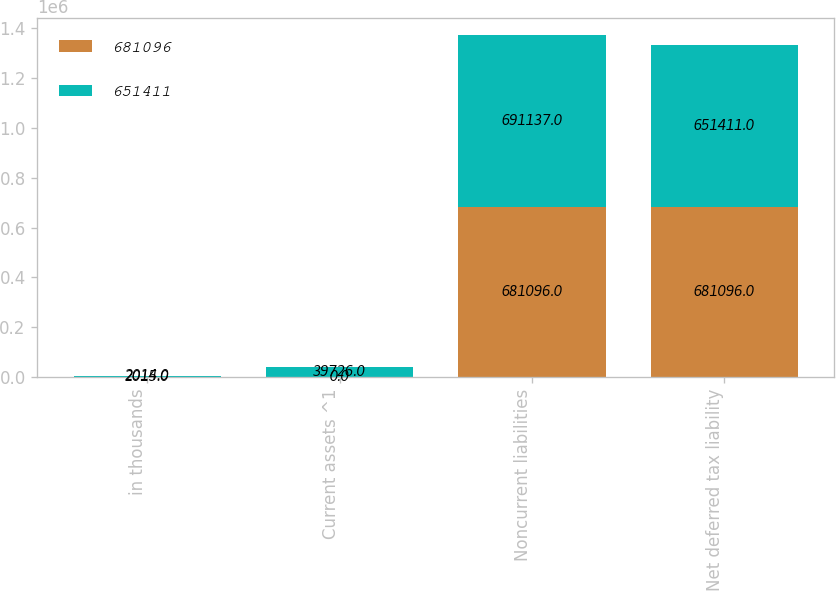<chart> <loc_0><loc_0><loc_500><loc_500><stacked_bar_chart><ecel><fcel>in thousands<fcel>Current assets ^1<fcel>Noncurrent liabilities<fcel>Net deferred tax liability<nl><fcel>681096<fcel>2015<fcel>0<fcel>681096<fcel>681096<nl><fcel>651411<fcel>2014<fcel>39726<fcel>691137<fcel>651411<nl></chart> 